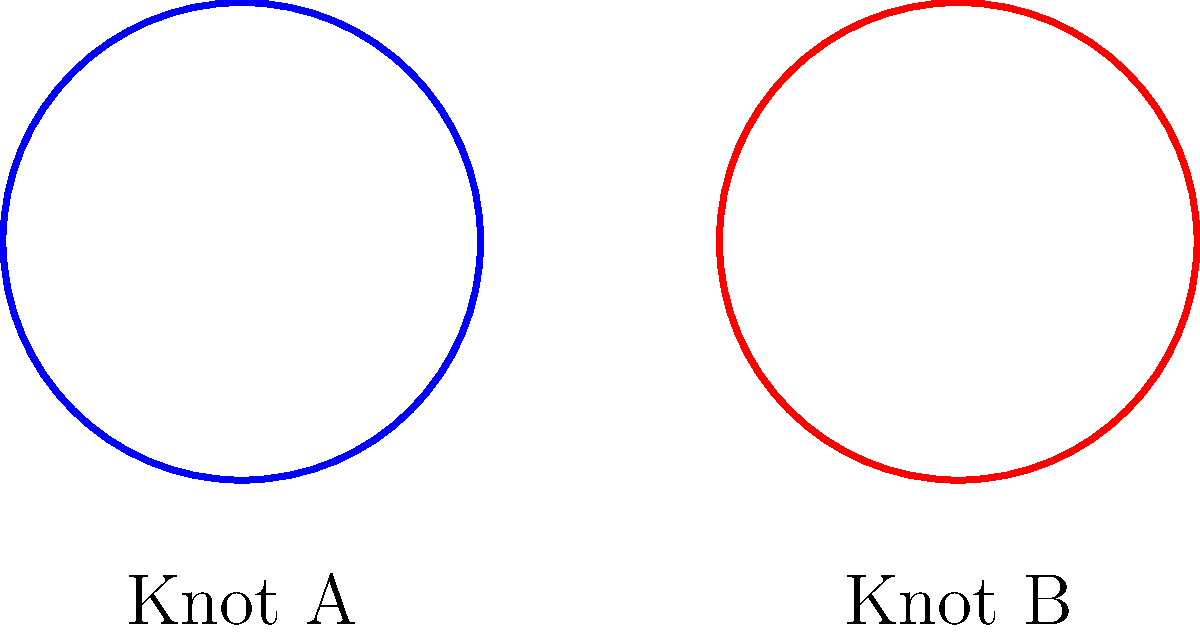Consider the two knot diagrams shown above, labeled as Knot A and Knot B. Are these knots homeomorphic to each other? Justify your answer. To determine if the two knots are homeomorphic, we need to follow these steps:

1. Understand the concept of homeomorphism:
   - Two knots are homeomorphic if one can be continuously deformed into the other without cutting or gluing.

2. Analyze Knot A:
   - Knot A is a simple closed curve with no crossings.
   - This type of knot is known as the unknot or trivial knot.

3. Analyze Knot B:
   - Knot B is also a simple closed curve with no crossings.
   - It is topologically equivalent to the unknot.

4. Compare Knot A and Knot B:
   - Both knots can be continuously deformed into a simple circle without cutting or gluing.
   - The apparent difference in shape is due to the embedding in 3D space, not their topological properties.

5. Apply the concept of homeomorphism:
   - Since both knots can be deformed into the same topological object (a circle), they are homeomorphic to each other.

Therefore, Knot A and Knot B are indeed homeomorphic.
Answer: Yes, the knots are homeomorphic. 